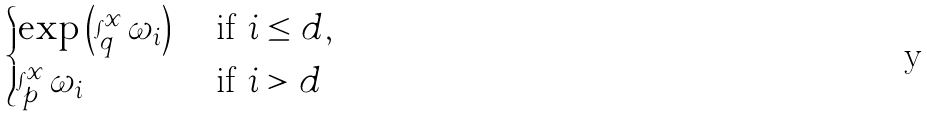Convert formula to latex. <formula><loc_0><loc_0><loc_500><loc_500>\begin{cases} \exp \left ( \int _ { q } ^ { x } \omega _ { i } \right ) & \text { if $i\leq d$} , \\ \int _ { p } ^ { x } \omega _ { i } & \text { if $i>d$} \end{cases}</formula> 